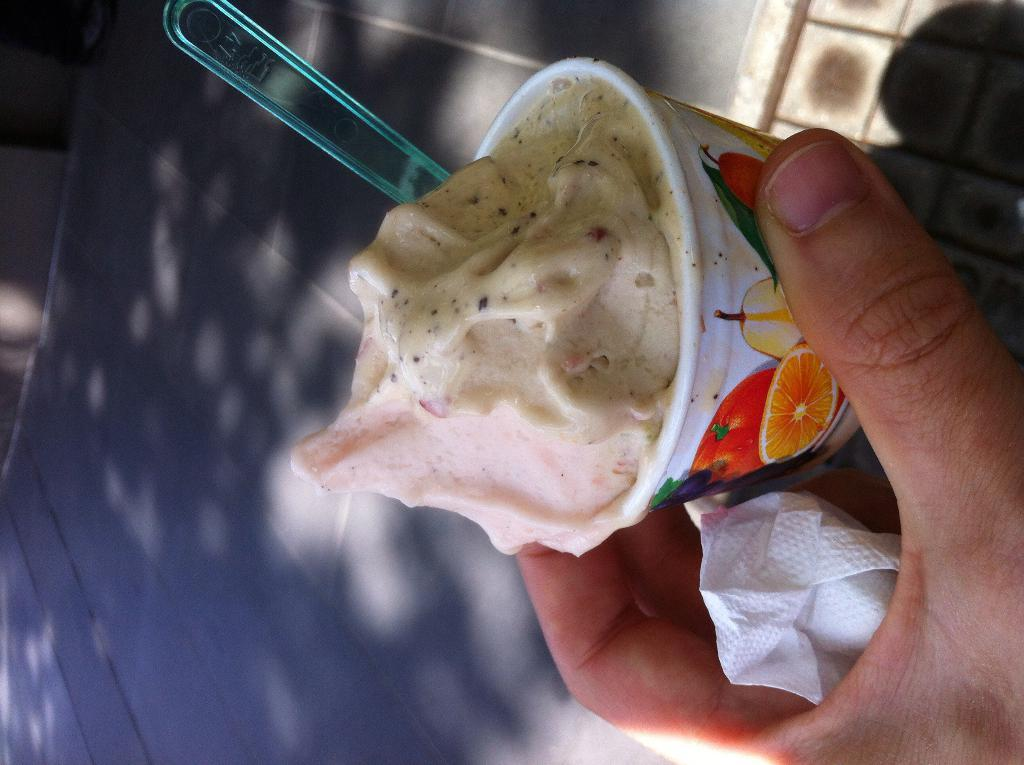What is being held in the foreground of the image? There is a person's hand holding a tissue in the foreground of the image. What else is the hand holding? The hand is holding an ice cream cup with a spoon in it. What is inside the ice cream cup? The ice cream cup contains some ice cream. What can be seen in the background of the image? There is ground visible in the background of the image. Is there a squirrel using the knife to cut the ice cream in the image? There is no knife or squirrel present in the image. 